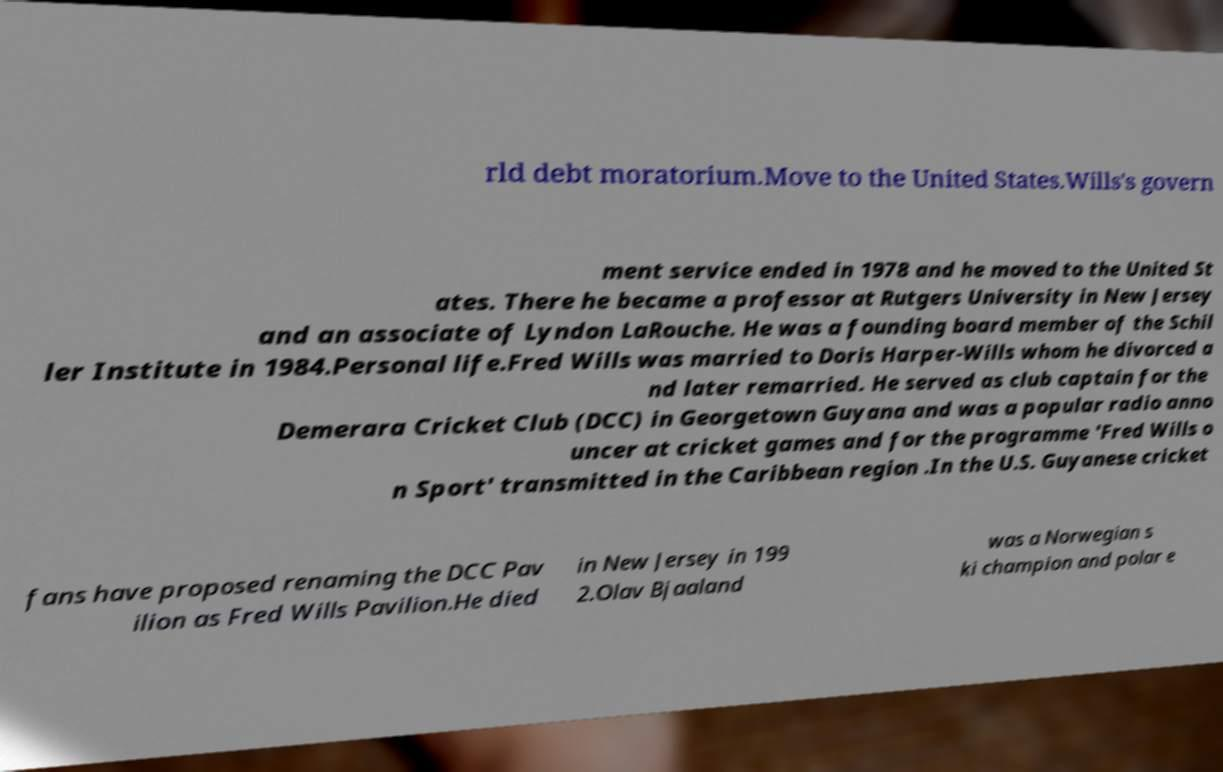Please read and relay the text visible in this image. What does it say? rld debt moratorium.Move to the United States.Wills's govern ment service ended in 1978 and he moved to the United St ates. There he became a professor at Rutgers University in New Jersey and an associate of Lyndon LaRouche. He was a founding board member of the Schil ler Institute in 1984.Personal life.Fred Wills was married to Doris Harper-Wills whom he divorced a nd later remarried. He served as club captain for the Demerara Cricket Club (DCC) in Georgetown Guyana and was a popular radio anno uncer at cricket games and for the programme 'Fred Wills o n Sport' transmitted in the Caribbean region .In the U.S. Guyanese cricket fans have proposed renaming the DCC Pav ilion as Fred Wills Pavilion.He died in New Jersey in 199 2.Olav Bjaaland was a Norwegian s ki champion and polar e 